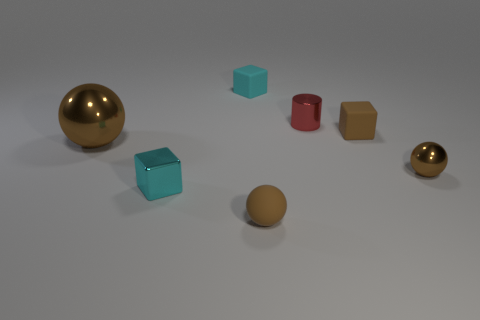Is there any other thing that is the same shape as the red shiny thing?
Offer a terse response. No. The cylinder is what color?
Offer a terse response. Red. What is the color of the other metallic object that is the same shape as the big object?
Your answer should be compact. Brown. How many big shiny objects are the same shape as the small red thing?
Keep it short and to the point. 0. What number of objects are either brown metal balls or tiny rubber cubes that are behind the metallic cylinder?
Offer a terse response. 3. Is the color of the big shiny thing the same as the ball on the right side of the tiny red object?
Keep it short and to the point. Yes. What is the size of the brown sphere that is left of the small red shiny cylinder and on the right side of the big brown sphere?
Offer a very short reply. Small. There is a brown matte ball; are there any small shiny things on the right side of it?
Keep it short and to the point. Yes. Are there any matte objects behind the small cyan object behind the tiny brown block?
Your response must be concise. No. Is the number of tiny matte blocks behind the small cyan matte thing the same as the number of small red cylinders in front of the tiny cyan shiny cube?
Provide a succinct answer. Yes. 